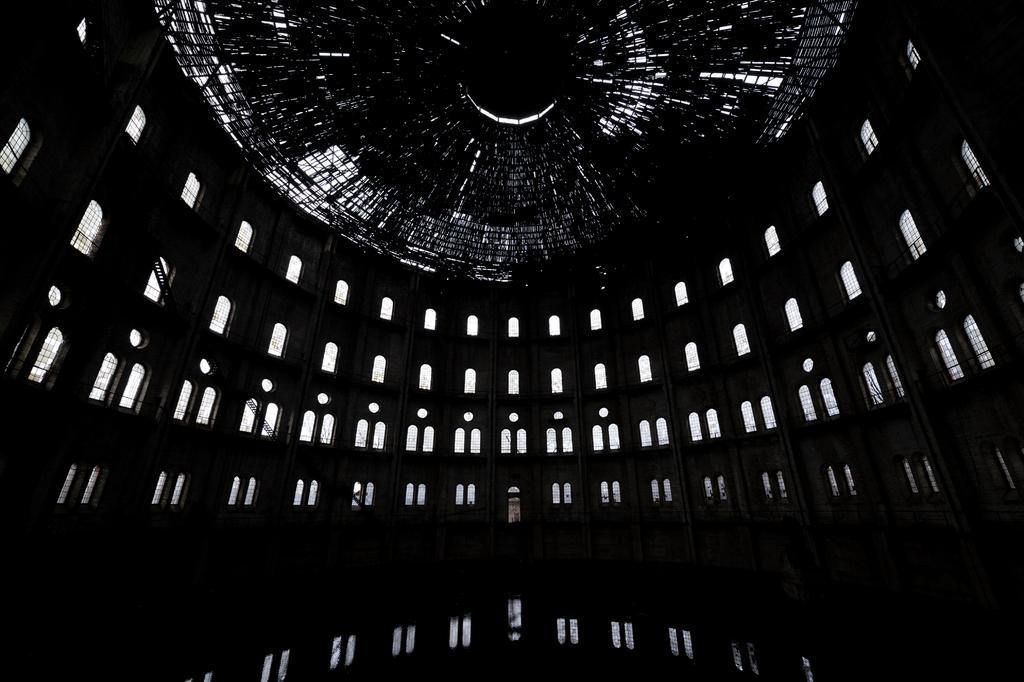What can be seen through the windows in the image? The image provides an inside view of a building, so we cannot see through the windows in the image. What type of building is shown in the image? The image provides an inside view of a building, but we cannot determine the specific type of building from the provided facts. What type of liquid is flowing through the system in the image? There is no system or liquid present in the image; it provides an inside view of a building with windows. 